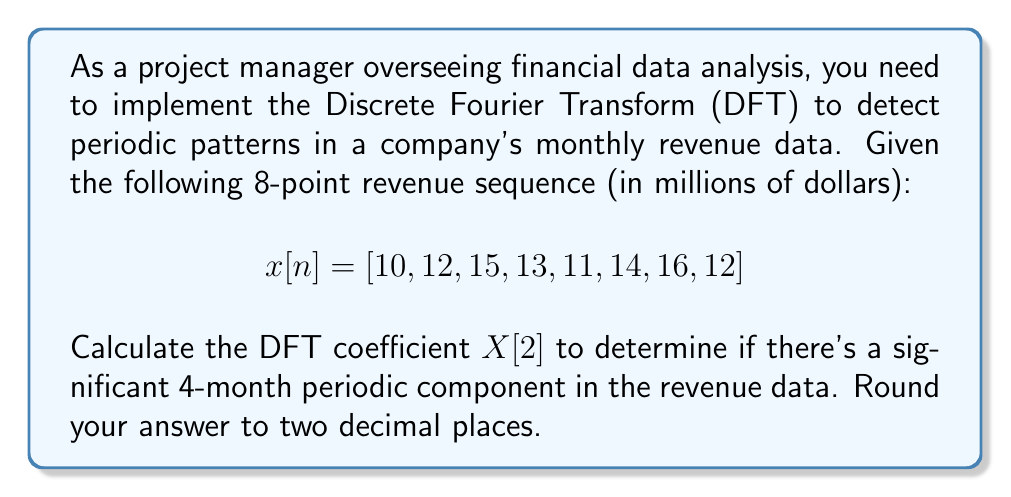Can you solve this math problem? To solve this problem, we'll follow these steps:

1) The Discrete Fourier Transform (DFT) for a sequence of N points is given by:

   $$X[k] = \sum_{n=0}^{N-1} x[n] \cdot e^{-j2\pi kn/N}$$

   where $k = 0, 1, ..., N-1$

2) In this case, we need to calculate $X[2]$ for an 8-point sequence, so $N = 8$ and $k = 2$:

   $$X[2] = \sum_{n=0}^{7} x[n] \cdot e^{-j2\pi (2)n/8}$$

3) Expand this using Euler's formula: $e^{-jx} = \cos(x) - j\sin(x)$

   $$X[2] = \sum_{n=0}^{7} x[n] \cdot (\cos(\frac{\pi n}{2}) - j\sin(\frac{\pi n}{2}))$$

4) Now, let's calculate each term:

   $n = 0$: $10 \cdot (1 - j0) = 10$
   $n = 1$: $12 \cdot (0 - j1) = -12j$
   $n = 2$: $15 \cdot (-1 - j0) = -15$
   $n = 3$: $13 \cdot (0 + j1) = 13j$
   $n = 4$: $11 \cdot (1 - j0) = 11$
   $n = 5$: $14 \cdot (0 - j1) = -14j$
   $n = 6$: $16 \cdot (-1 - j0) = -16$
   $n = 7$: $12 \cdot (0 + j1) = 12j$

5) Sum all these terms:

   $X[2] = (10 - 15 + 11 - 16) + (-12 + 13 - 14 + 12)j$

6) Simplify:

   $X[2] = -10 - j$

7) To get the magnitude (which represents the strength of this frequency component):

   $|X[2]| = \sqrt{(-10)^2 + (-1)^2} = \sqrt{101} \approx 10.05$

The magnitude of $X[2]$ (approximately 10.05) represents the strength of the 4-month periodic component in the revenue data. This is a significant value compared to the average revenue, indicating a strong 4-month periodicity in the data.
Answer: $|X[2]| \approx 10.05$ 